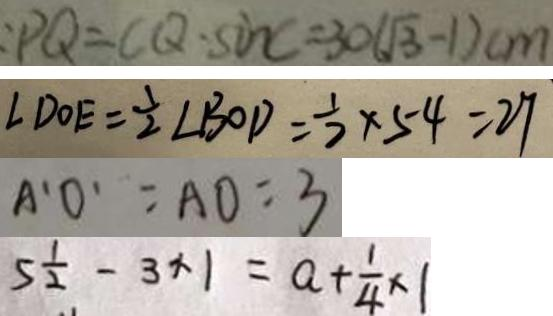Convert formula to latex. <formula><loc_0><loc_0><loc_500><loc_500>: P Q = C Q \cdot \sin C = 3 0 ( \sqrt { 3 } - 1 ) c m 
 \angle D O E = \frac { 1 } { 2 } \angle B O D = \frac { 1 } { 2 } \times 5 4 = 2 7 
 A ^ { \prime } O ^ { \prime } = A O = 3 
 5 \frac { 1 } { 2 } - 3 \times 1 = a + \frac { 1 } { 4 } \times 1</formula> 